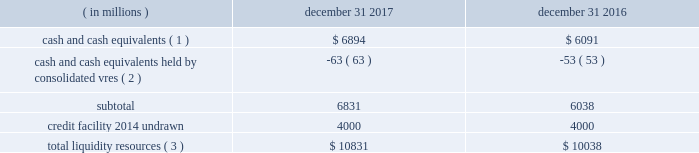Sources of blackrock 2019s operating cash primarily include investment advisory , administration fees and securities lending revenue , performance fees , revenue from technology and risk management services , advisory and other revenue and distribution fees .
Blackrock uses its cash to pay all operating expense , interest and principal on borrowings , income taxes , dividends on blackrock 2019s capital stock , repurchases of the company 2019s stock , capital expenditures and purchases of co-investments and seed investments .
For details of the company 2019s gaap cash flows from operating , investing and financing activities , see the consolidated statements of cash flows contained in part ii , item 8 of this filing .
Cash flows from operating activities , excluding the impact of consolidated sponsored investment funds , primarily include the receipt of investment advisory and administration fees , securities lending revenue and performance fees offset by the payment of operating expenses incurred in the normal course of business , including year-end incentive compensation accrued for in the prior year .
Cash outflows from investing activities , excluding the impact of consolidated sponsored investment funds , for 2017 were $ 517 million and primarily reflected $ 497 million of investment purchases , $ 155 million of purchases of property and equipment , $ 73 million related to the first reserve transaction and $ 29 million related to the cachematrix transaction , partially offset by $ 205 million of net proceeds from sales and maturities of certain investments .
Cash outflows from financing activities , excluding the impact of consolidated sponsored investment funds , for 2017 were $ 3094 million , primarily resulting from $ 1.4 billion of share repurchases , including $ 1.1 billion in open market- transactions and $ 321 million of employee tax withholdings related to employee stock transactions , $ 1.7 billion of cash dividend payments and $ 700 million of repayments of long- term borrowings , partially offset by $ 697 million of proceeds from issuance of long-term borrowings .
The company manages its financial condition and funding to maintain appropriate liquidity for the business .
Liquidity resources at december 31 , 2017 and 2016 were as follows : ( in millions ) december 31 , december 31 , cash and cash equivalents ( 1 ) $ 6894 $ 6091 cash and cash equivalents held by consolidated vres ( 2 ) ( 63 ) ( 53 ) .
Total liquidity resources ( 3 ) $ 10831 $ 10038 ( 1 ) the percentage of cash and cash equivalents held by the company 2019s u.s .
Subsidiaries was approximately 40% ( 40 % ) and 50% ( 50 % ) at december 31 , 2017 and 2016 , respectively .
See net capital requirements herein for more information on net capital requirements in certain regulated subsidiaries .
( 2 ) the company cannot readily access such cash to use in its operating activities .
( 3 ) amounts do not reflect a reduction for year-end incentive compensation accruals of approximately $ 1.5 billion and $ 1.3 billion for 2017 and 2016 , respectively , which are paid in the first quarter of the following year .
Total liquidity resources increased $ 793 million during 2017 , primarily reflecting cash flows from operating activities , partially offset by cash payments of 2016 year-end incentive awards , share repurchases of $ 1.4 billion and cash dividend payments of $ 1.7 billion .
A significant portion of the company 2019s $ 3154 million of total investments , as adjusted , is illiquid in nature and , as such , cannot be readily convertible to cash .
Share repurchases .
The company repurchased 2.6 million common shares in open market transactions under the share repurchase program for approximately $ 1.1 billion during 2017 .
At december 31 , 2017 , there were 6.4 million shares still authorized to be repurchased .
Net capital requirements .
The company is required to maintain net capital in certain regulated subsidiaries within a number of jurisdictions , which is partially maintained by retaining cash and cash equivalent investments in those subsidiaries or jurisdictions .
As a result , such subsidiaries of the company may be restricted in their ability to transfer cash between different jurisdictions and to their parents .
Additionally , transfers of cash between international jurisdictions may have adverse tax consequences that could discourage such transfers .
Blackrock institutional trust company , n.a .
( 201cbtc 201d ) is chartered as a national bank that does not accept client deposits and whose powers are limited to trust and other fiduciary activities .
Btc provides investment management services , including investment advisory and securities lending agency services , to institutional clients .
Btc is subject to regulatory capital and liquid asset requirements administered by the office of the comptroller of the currency .
At december 31 , 2017 and 2016 , the company was required to maintain approximately $ 1.8 billion and $ 1.4 billion , respectively , in net capital in certain regulated subsidiaries , including btc , entities regulated by the financial conduct authority and prudential regulation authority in the united kingdom , and the company 2019s broker-dealers .
The company was in compliance with all applicable regulatory net capital requirements .
Undistributed earnings of foreign subsidiaries .
As a result of the 2017 tax act and the one-time mandatory deemed repatriation tax on untaxed accumulated foreign earnings , a provisional amount of u.s .
Income taxes was provided on the undistributed foreign earnings .
The financial statement basis in excess of tax basis of its foreign subsidiaries remains indefinitely reinvested in foreign operations .
The company will continue to evaluate its capital management plans throughout 2018 .
Short-term borrowings 2017 revolving credit facility .
The company 2019s credit facility has an aggregate commitment amount of $ 4.0 billion and was amended in april 2017 to extend the maturity date to april 2022 ( the 201c2017 credit facility 201d ) .
The 2017 credit facility permits the company to request up to an additional $ 1.0 billion of borrowing capacity , subject to lender credit approval , increasing the overall size of the 2017 credit facility to an aggregate principal amount not to exceed $ 5.0 billion .
Interest on borrowings outstanding accrues at a rate based on the applicable london interbank offered rate plus a spread .
The 2017 credit facility requires the company .
How much more cash was held in 2017 than 2016 ? in million$ .? 
Computations: (6894 - 6091)
Answer: 803.0. 